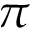Convert formula to latex. <formula><loc_0><loc_0><loc_500><loc_500>\pi</formula> 